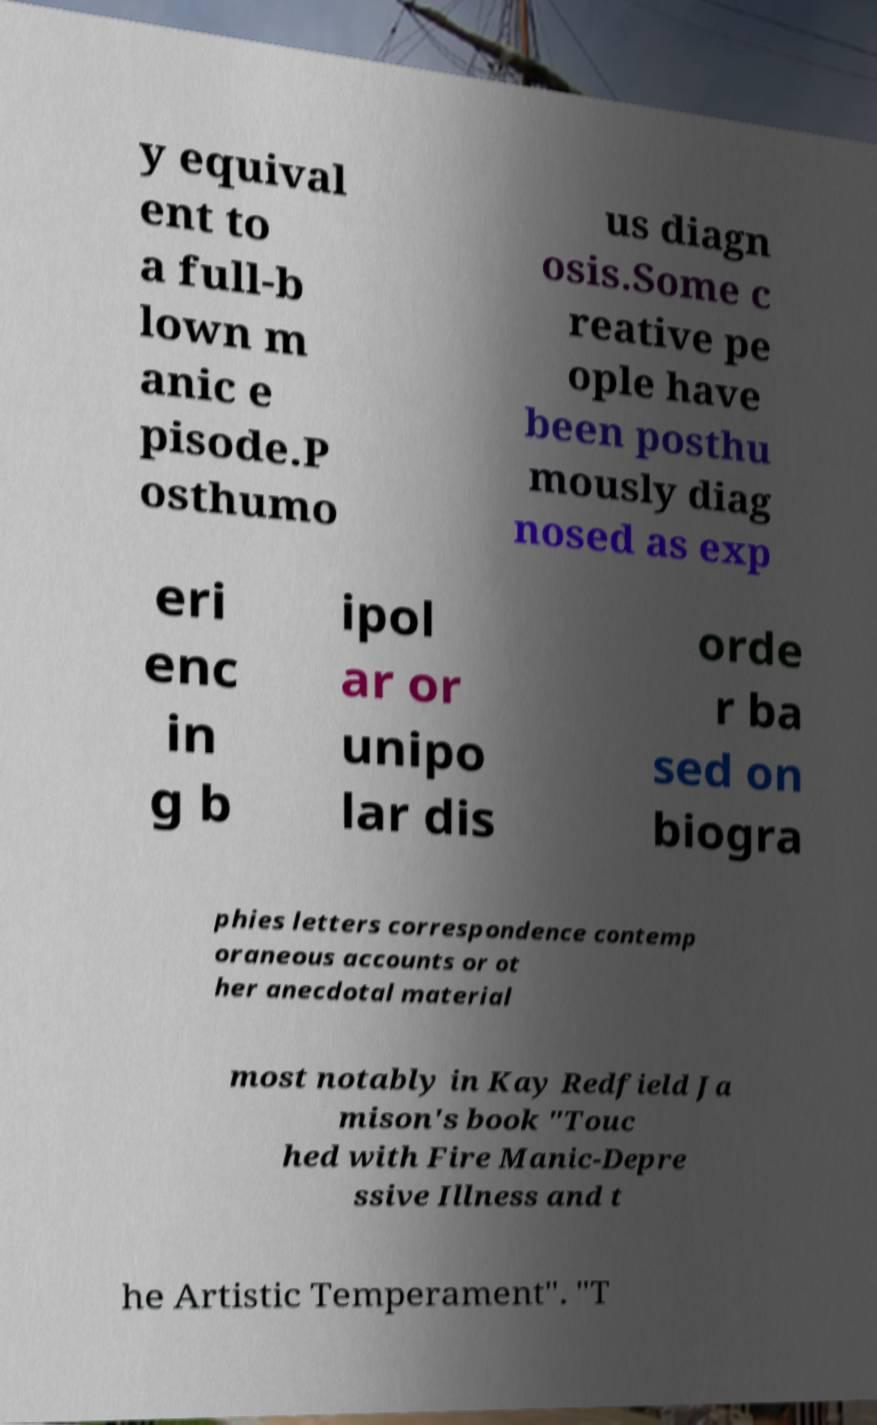Could you assist in decoding the text presented in this image and type it out clearly? y equival ent to a full-b lown m anic e pisode.P osthumo us diagn osis.Some c reative pe ople have been posthu mously diag nosed as exp eri enc in g b ipol ar or unipo lar dis orde r ba sed on biogra phies letters correspondence contemp oraneous accounts or ot her anecdotal material most notably in Kay Redfield Ja mison's book "Touc hed with Fire Manic-Depre ssive Illness and t he Artistic Temperament". "T 